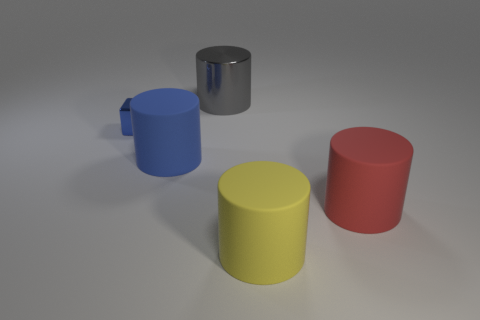Add 4 large red things. How many objects exist? 9 Subtract all cylinders. How many objects are left? 1 Subtract 0 brown cubes. How many objects are left? 5 Subtract all small blue blocks. Subtract all large purple metal cylinders. How many objects are left? 4 Add 4 blue metallic blocks. How many blue metallic blocks are left? 5 Add 4 tiny objects. How many tiny objects exist? 5 